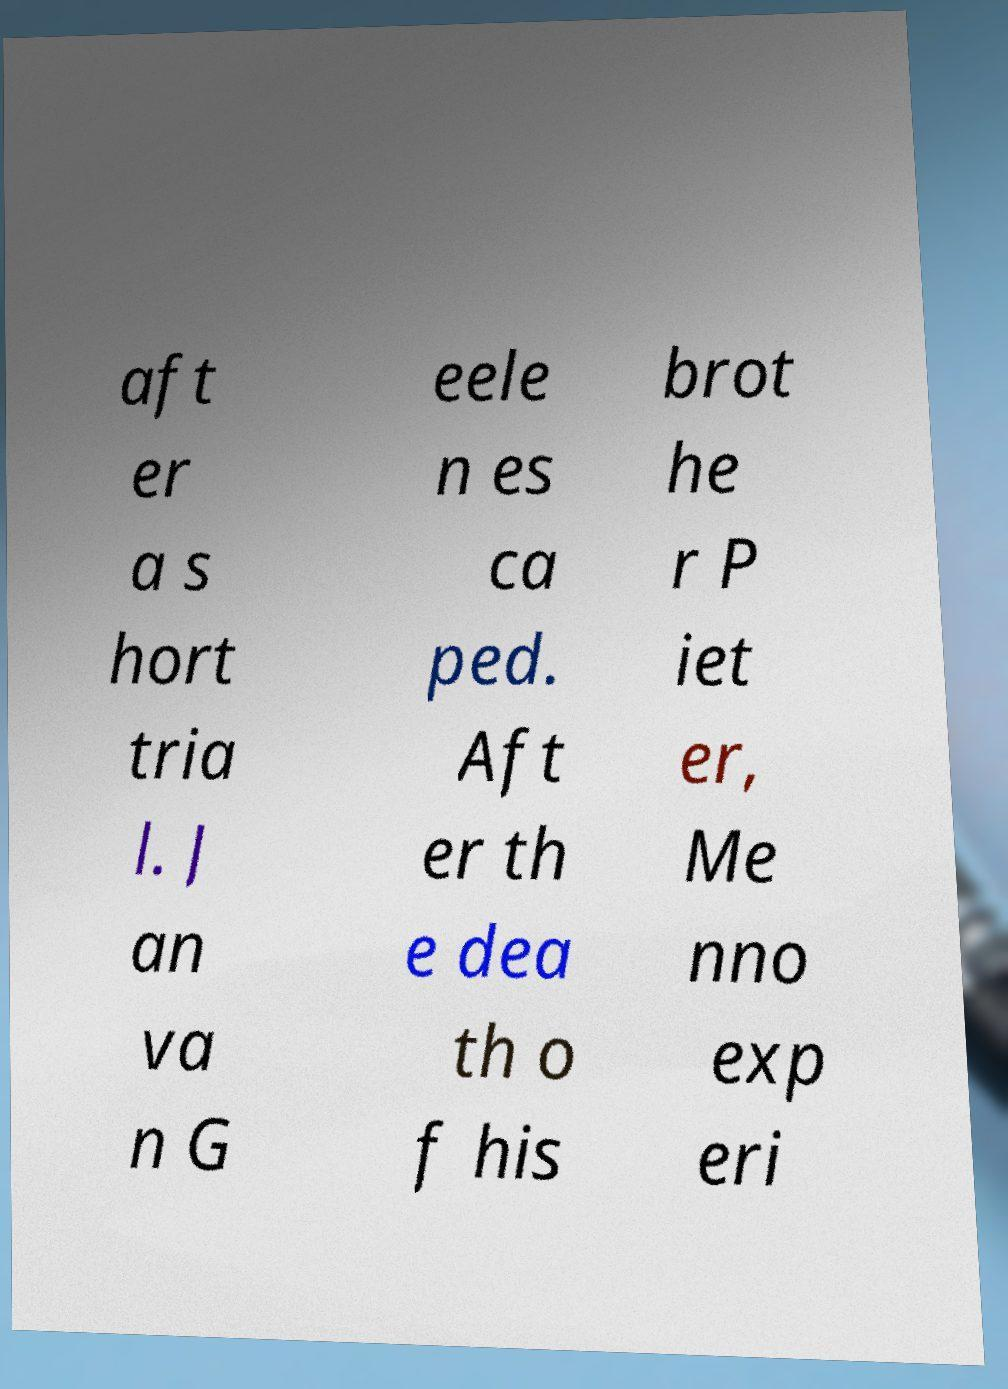I need the written content from this picture converted into text. Can you do that? aft er a s hort tria l. J an va n G eele n es ca ped. Aft er th e dea th o f his brot he r P iet er, Me nno exp eri 